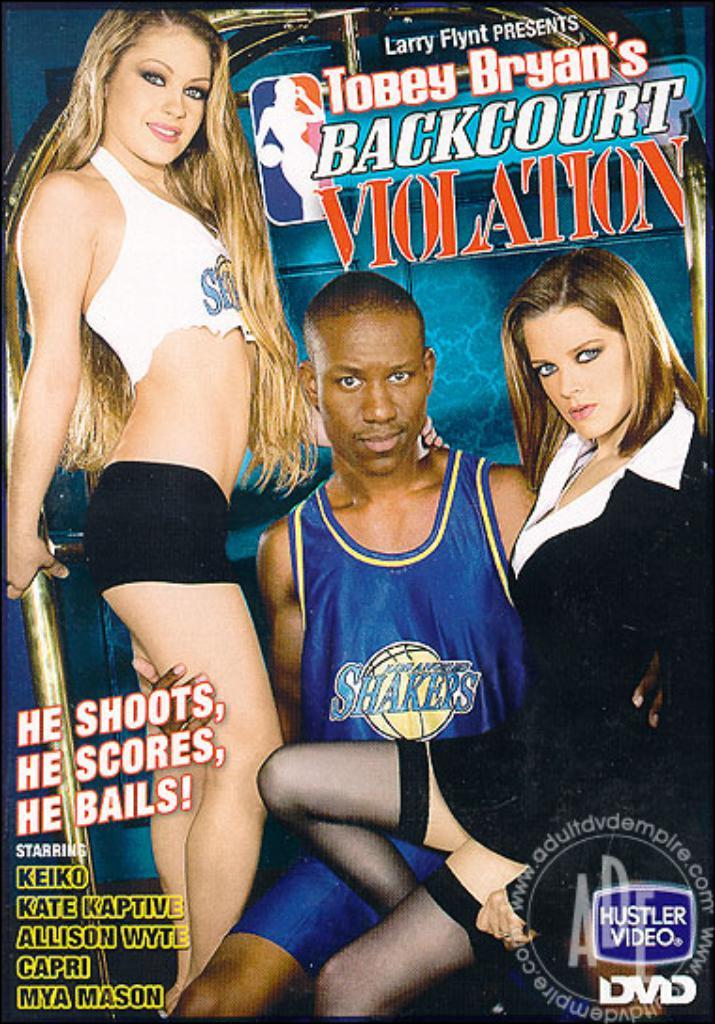What type of visual is the image? The image is a poster. Who is depicted in the poster? There is a man and two women in the poster. What are the expressions of the people in the poster? The man and women are smiling. Is there any text on the poster? Yes, there is text on the poster. What is the weather like in the poster? The poster does not depict any weather conditions, as it is a static image of people smiling. How does the poster address the issue of pollution? The poster does not address the issue of pollution, as the provided facts do not mention any related content. 